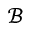Convert formula to latex. <formula><loc_0><loc_0><loc_500><loc_500>\mathcal { B }</formula> 